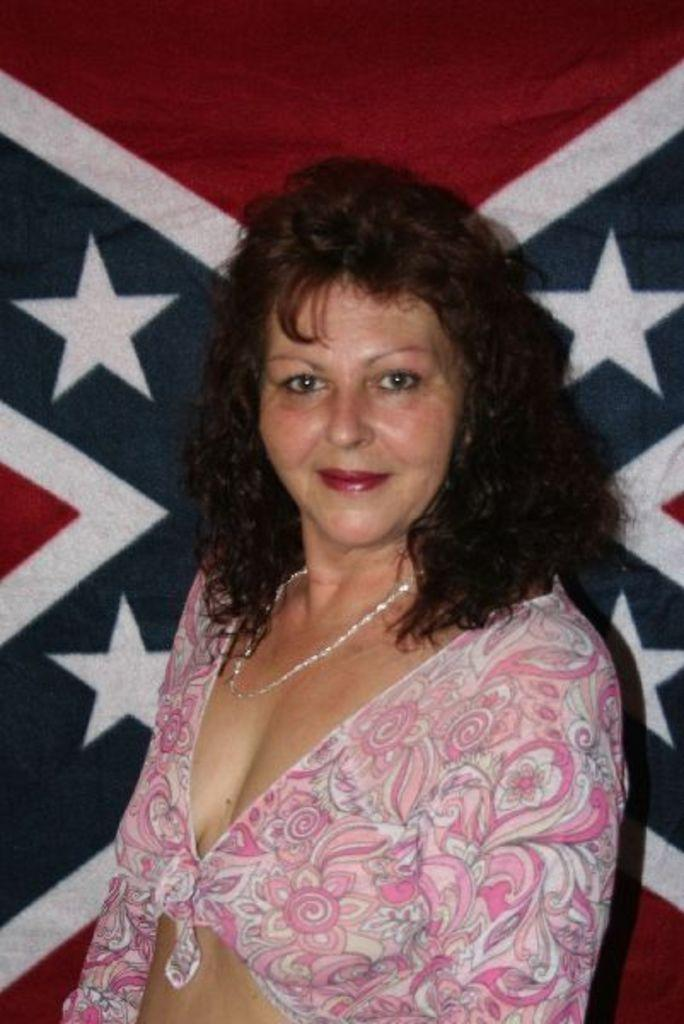Who is present in the image? There is a woman in the image. What is the woman wearing? The woman is wearing a pink dress. Can you describe the object behind the woman? Unfortunately, the facts provided do not give enough information to describe the object behind the woman. What type of orange stamp can be seen on the woman's dress? There is no orange stamp present on the woman's dress in the image. 